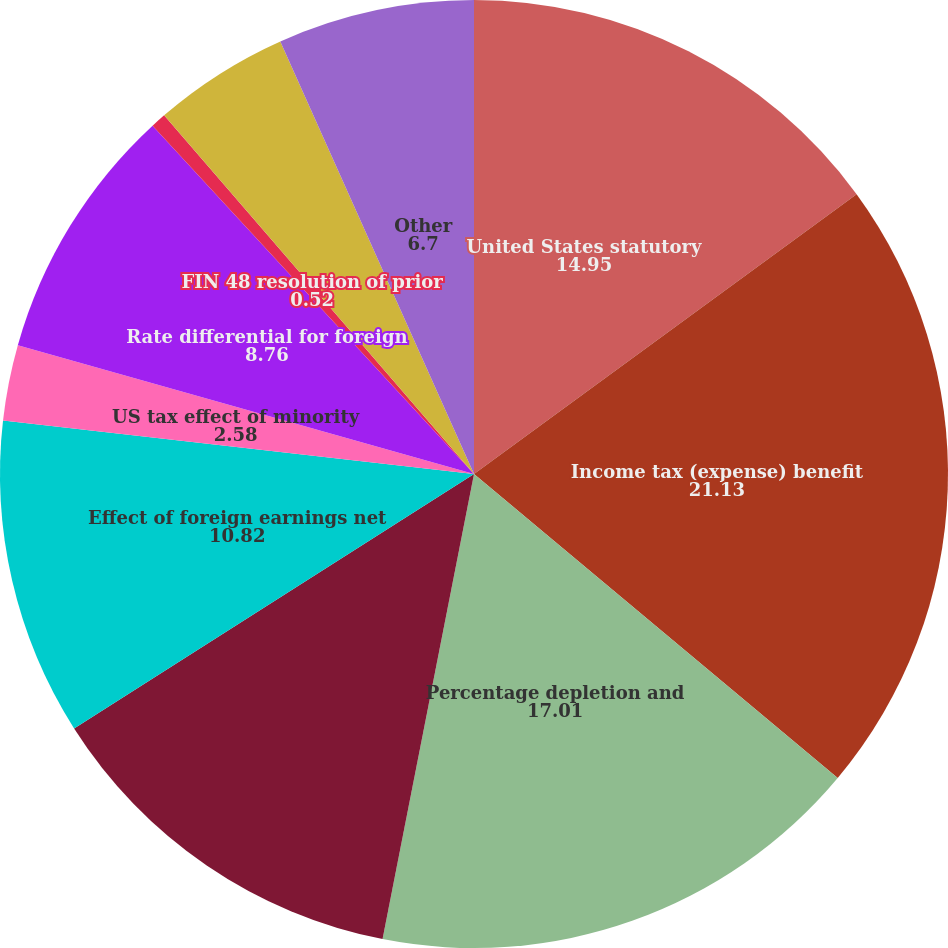Convert chart to OTSL. <chart><loc_0><loc_0><loc_500><loc_500><pie_chart><fcel>United States statutory<fcel>Income tax (expense) benefit<fcel>Percentage depletion and<fcel>Change in valuation allowance<fcel>Effect of foreign earnings net<fcel>US tax effect of minority<fcel>Rate differential for foreign<fcel>FIN 48 resolution of prior<fcel>Tax effect of changes in tax<fcel>Other<nl><fcel>14.95%<fcel>21.13%<fcel>17.01%<fcel>12.89%<fcel>10.82%<fcel>2.58%<fcel>8.76%<fcel>0.52%<fcel>4.64%<fcel>6.7%<nl></chart> 